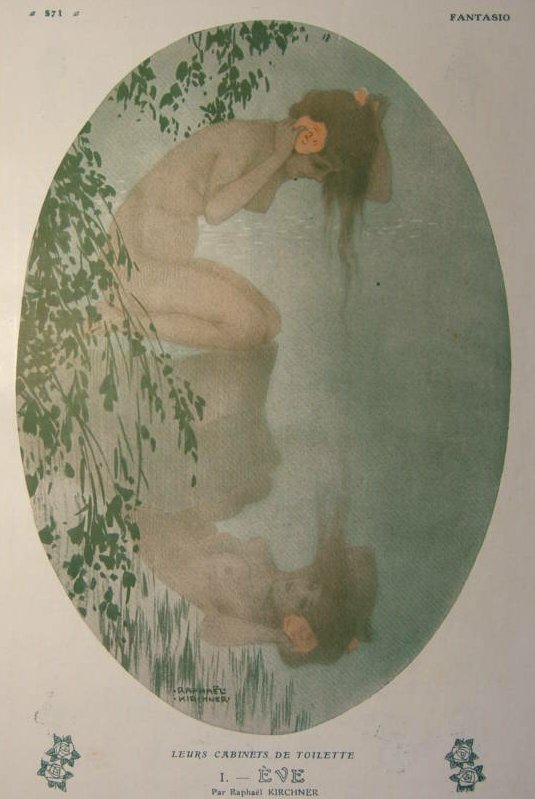Describe the following image. The image is a beautiful example of Art Nouveau, characterized by its intricate designs and whimsical elements. It portrays a woman in an ethereal pose, kneeling beside a reflective body of water. She is depicted as holding a pink flower close to her face, immersed in a moment of serene introspection. The color scheme is predominantly soft greens and nature-inspired hues, which complement the tranquil ambiance of the scene. The setting is further embellished with lush green foliage cascading around the woman, forming an oval frame that focuses the viewer's attention on her. The artwork also features text that reads "LEURS CABINETS DE TOILETTE Par Raphael Kirchner FANTASIO," indicating the artist and a possible series or publication to which the work belongs. 